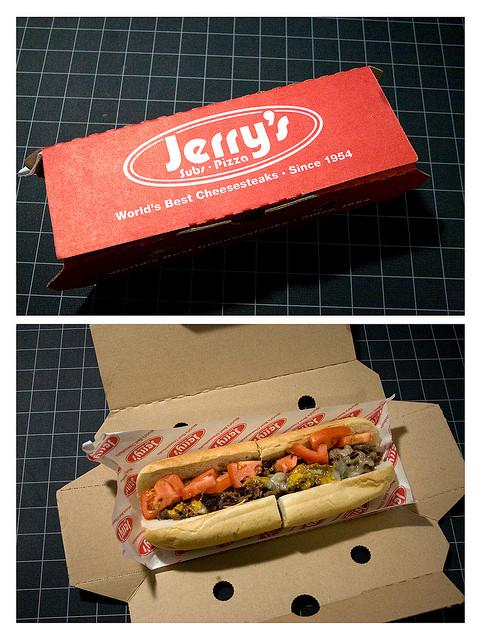Has someone started eating this sandwich?
Answer briefly. No. What restaurant is the sandwich from?
Keep it brief. Jerry's. Are there tomatoes on this sandwich?
Write a very short answer. Yes. 